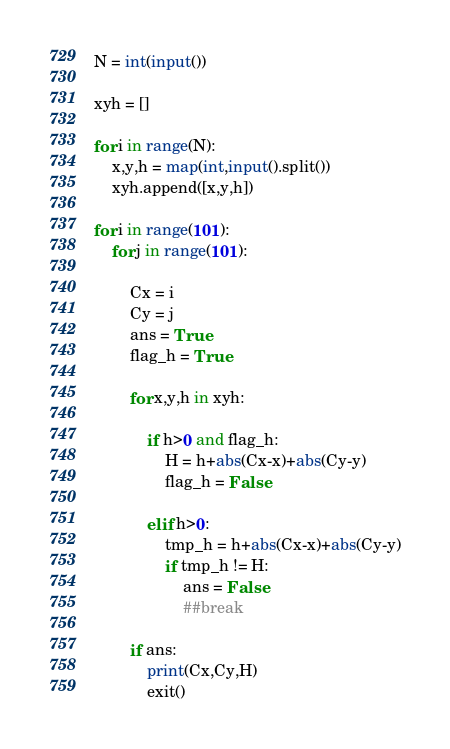Convert code to text. <code><loc_0><loc_0><loc_500><loc_500><_Python_>N = int(input())

xyh = []

for i in range(N):
    x,y,h = map(int,input().split())
    xyh.append([x,y,h])

for i in range(101):
    for j in range(101):

        Cx = i
        Cy = j
        ans = True
        flag_h = True

        for x,y,h in xyh:

            if h>0 and flag_h:
                H = h+abs(Cx-x)+abs(Cy-y)
                flag_h = False

            elif h>0:
                tmp_h = h+abs(Cx-x)+abs(Cy-y)
                if tmp_h != H:
                    ans = False
                    ##break

        if ans:
            print(Cx,Cy,H)
            exit()</code> 